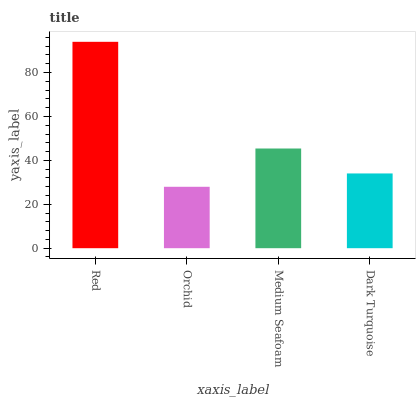Is Orchid the minimum?
Answer yes or no. Yes. Is Red the maximum?
Answer yes or no. Yes. Is Medium Seafoam the minimum?
Answer yes or no. No. Is Medium Seafoam the maximum?
Answer yes or no. No. Is Medium Seafoam greater than Orchid?
Answer yes or no. Yes. Is Orchid less than Medium Seafoam?
Answer yes or no. Yes. Is Orchid greater than Medium Seafoam?
Answer yes or no. No. Is Medium Seafoam less than Orchid?
Answer yes or no. No. Is Medium Seafoam the high median?
Answer yes or no. Yes. Is Dark Turquoise the low median?
Answer yes or no. Yes. Is Red the high median?
Answer yes or no. No. Is Medium Seafoam the low median?
Answer yes or no. No. 